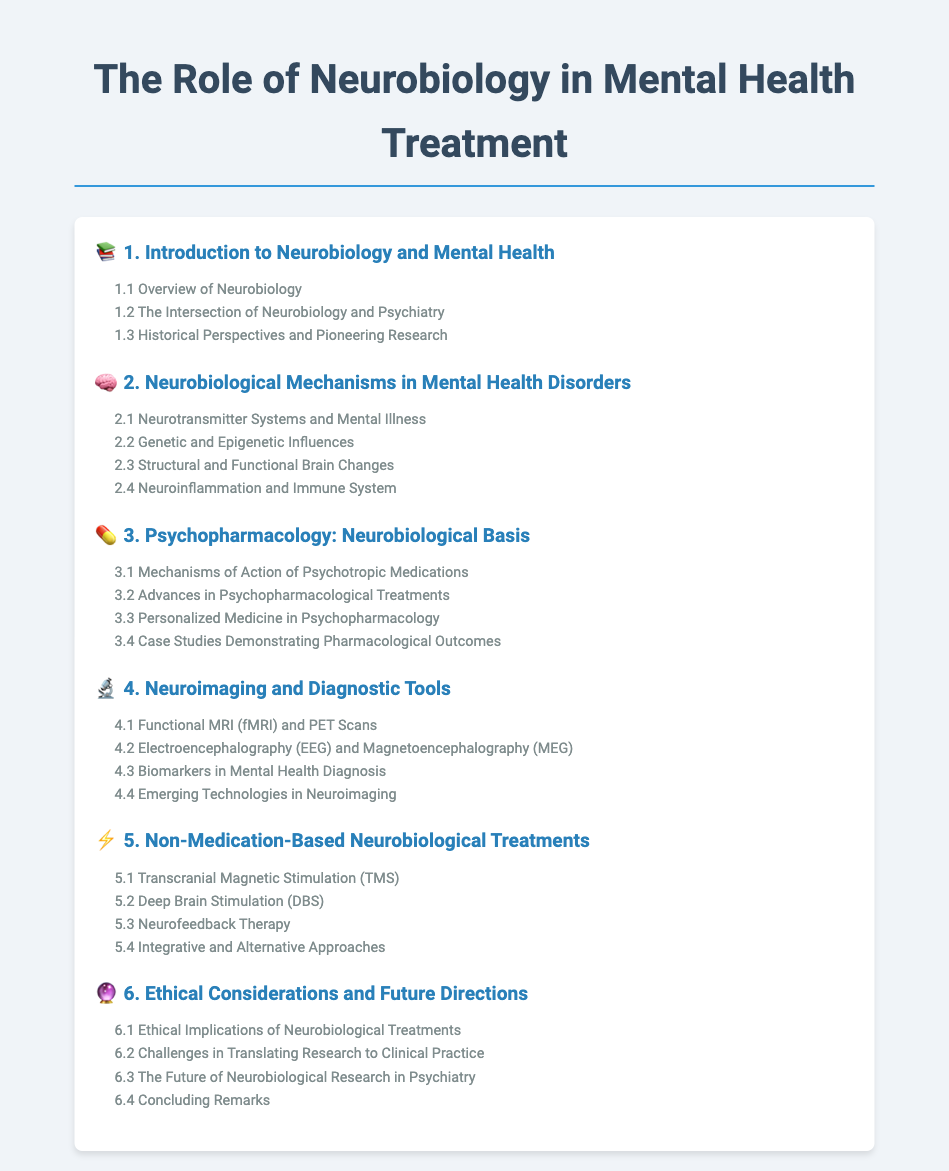what is the title of the document? The title of the document is located at the top of the rendered document.
Answer: The Role of Neurobiology in Mental Health Treatment how many main sections are there in the table of contents? The main sections are listed sequentially in the document.
Answer: 6 what is the first subsection of the introduction section? The subsections under the Introduction section are listed directly below the main section title.
Answer: Overview of Neurobiology which neurobiological treatment involves stimulation of the brain? One of the subsections under the Non-Medication-Based Neurobiological Treatments section refers specifically to this treatment.
Answer: Transcranial Magnetic Stimulation (TMS) what is the focus of section 2 in the document? The title of the second section summarizes its content area.
Answer: Neurobiological Mechanisms in Mental Health Disorders which subsection discusses the implications of neurobiological treatments? This information is found in the Ethical Considerations and Future Directions section.
Answer: Ethical Implications of Neurobiological Treatments what advanced imaging technique is mentioned in section 4? The relevant subsection titles of the Neuroimaging and Diagnostic Tools section indicate the techniques discussed.
Answer: Functional MRI (fMRI) and PET Scans what concept is related to personalized medicine in section 3? The title of the subsection gives a clear indication of this concept.
Answer: Personalized Medicine in Psychopharmacology 